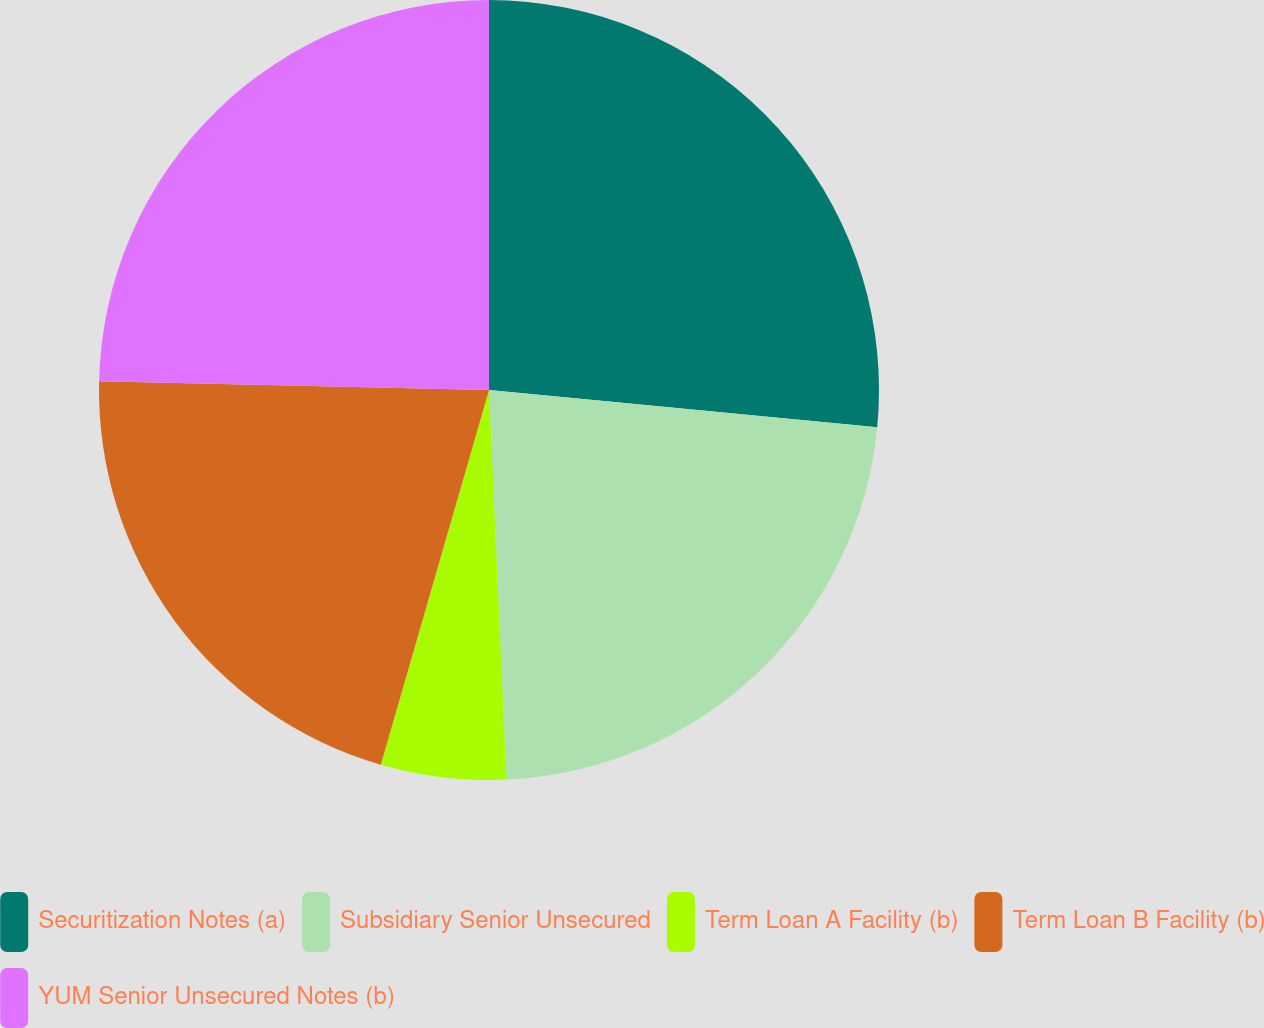<chart> <loc_0><loc_0><loc_500><loc_500><pie_chart><fcel>Securitization Notes (a)<fcel>Subsidiary Senior Unsecured<fcel>Term Loan A Facility (b)<fcel>Term Loan B Facility (b)<fcel>YUM Senior Unsecured Notes (b)<nl><fcel>26.52%<fcel>22.76%<fcel>5.19%<fcel>20.88%<fcel>24.64%<nl></chart> 